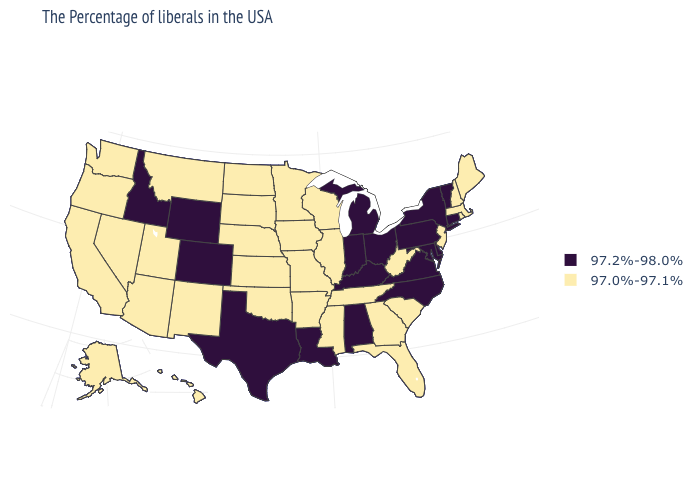What is the highest value in states that border Nebraska?
Concise answer only. 97.2%-98.0%. Does West Virginia have the lowest value in the USA?
Keep it brief. Yes. Does Louisiana have the same value as North Carolina?
Short answer required. Yes. Does Utah have the lowest value in the USA?
Answer briefly. Yes. Name the states that have a value in the range 97.2%-98.0%?
Answer briefly. Vermont, Connecticut, New York, Delaware, Maryland, Pennsylvania, Virginia, North Carolina, Ohio, Michigan, Kentucky, Indiana, Alabama, Louisiana, Texas, Wyoming, Colorado, Idaho. Does the first symbol in the legend represent the smallest category?
Write a very short answer. No. What is the value of North Carolina?
Write a very short answer. 97.2%-98.0%. Name the states that have a value in the range 97.2%-98.0%?
Write a very short answer. Vermont, Connecticut, New York, Delaware, Maryland, Pennsylvania, Virginia, North Carolina, Ohio, Michigan, Kentucky, Indiana, Alabama, Louisiana, Texas, Wyoming, Colorado, Idaho. Which states have the highest value in the USA?
Be succinct. Vermont, Connecticut, New York, Delaware, Maryland, Pennsylvania, Virginia, North Carolina, Ohio, Michigan, Kentucky, Indiana, Alabama, Louisiana, Texas, Wyoming, Colorado, Idaho. What is the value of New Hampshire?
Write a very short answer. 97.0%-97.1%. Name the states that have a value in the range 97.0%-97.1%?
Give a very brief answer. Maine, Massachusetts, Rhode Island, New Hampshire, New Jersey, South Carolina, West Virginia, Florida, Georgia, Tennessee, Wisconsin, Illinois, Mississippi, Missouri, Arkansas, Minnesota, Iowa, Kansas, Nebraska, Oklahoma, South Dakota, North Dakota, New Mexico, Utah, Montana, Arizona, Nevada, California, Washington, Oregon, Alaska, Hawaii. What is the value of Oklahoma?
Answer briefly. 97.0%-97.1%. Does the first symbol in the legend represent the smallest category?
Give a very brief answer. No. What is the highest value in the USA?
Be succinct. 97.2%-98.0%. Does the map have missing data?
Give a very brief answer. No. 